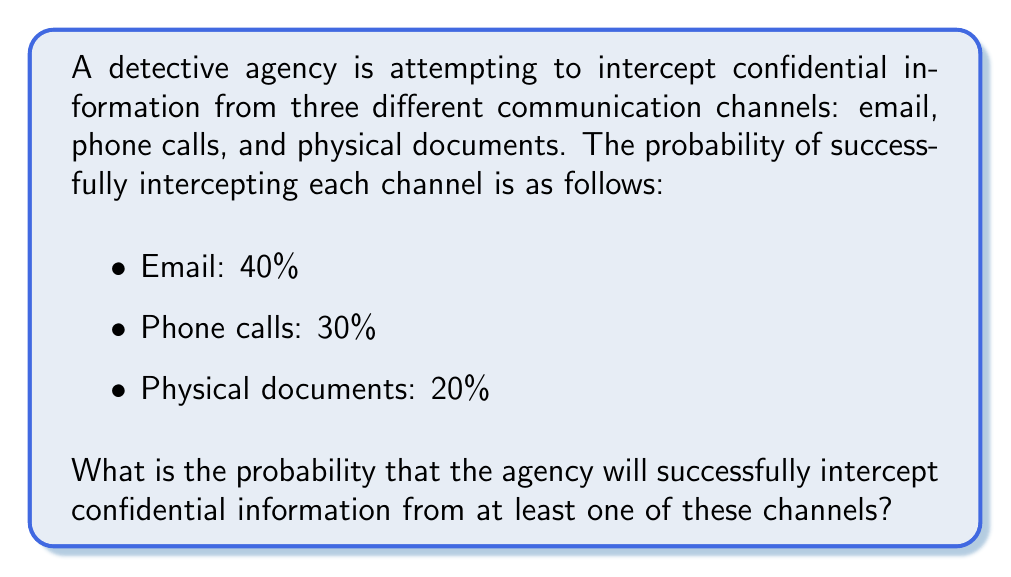Teach me how to tackle this problem. To solve this problem, we need to use the concept of probability of at least one event occurring, which is the complement of the probability that none of the events occur.

Let's define the events:
$E$: Successfully intercepting email
$P$: Successfully intercepting phone calls
$D$: Successfully intercepting physical documents

We want to find $P(E \cup P \cup D)$, which is the probability of at least one of these events occurring.

Step 1: Calculate the probability of each event not occurring:
$P(\text{not }E) = 1 - 0.40 = 0.60$
$P(\text{not }P) = 1 - 0.30 = 0.70$
$P(\text{not }D) = 1 - 0.20 = 0.80$

Step 2: Calculate the probability that none of the events occur:
$P(\text{none}) = P(\text{not }E \text{ and not }P \text{ and not }D)$
Assuming independence of events:
$P(\text{none}) = P(\text{not }E) \times P(\text{not }P) \times P(\text{not }D)$
$P(\text{none}) = 0.60 \times 0.70 \times 0.80 = 0.336$

Step 3: Calculate the probability of at least one event occurring:
$P(\text{at least one}) = 1 - P(\text{none})$
$P(\text{at least one}) = 1 - 0.336 = 0.664$

Therefore, the probability of successfully intercepting confidential information from at least one channel is 0.664 or 66.4%.
Answer: $0.664$ or $66.4\%$ 